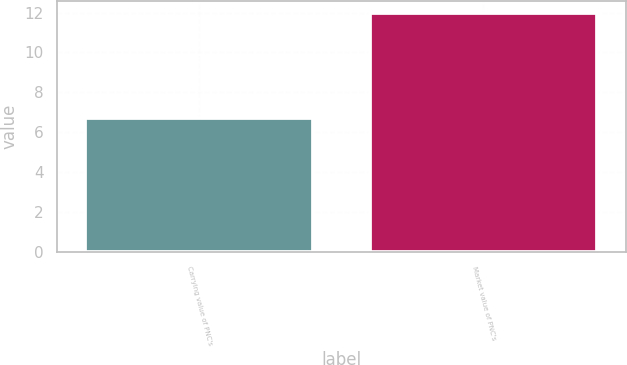<chart> <loc_0><loc_0><loc_500><loc_500><bar_chart><fcel>Carrying value of PNC's<fcel>Market value of PNC's<nl><fcel>6.7<fcel>12<nl></chart> 